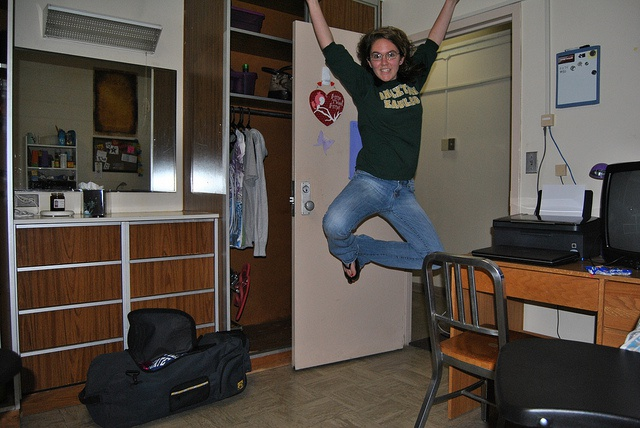Describe the objects in this image and their specific colors. I can see people in black, blue, and gray tones, suitcase in black, maroon, gray, and darkgray tones, chair in black, maroon, and gray tones, tv in black, purple, and gray tones, and laptop in black, gray, and maroon tones in this image. 